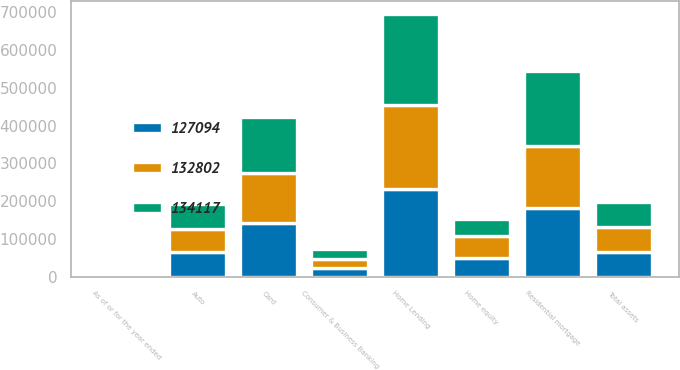Convert chart. <chart><loc_0><loc_0><loc_500><loc_500><stacked_bar_chart><ecel><fcel>As of or for the year ended<fcel>Total assets<fcel>Consumer & Business Banking<fcel>Home equity<fcel>Residential mortgage<fcel>Home Lending<fcel>Card<fcel>Auto<nl><fcel>134117<fcel>2017<fcel>65814<fcel>25789<fcel>42751<fcel>197339<fcel>240090<fcel>149511<fcel>66242<nl><fcel>127094<fcel>2016<fcel>65814<fcel>24307<fcel>50296<fcel>181196<fcel>231492<fcel>141816<fcel>65814<nl><fcel>132802<fcel>2015<fcel>65814<fcel>22730<fcel>58734<fcel>164500<fcel>223234<fcel>131463<fcel>60255<nl></chart> 